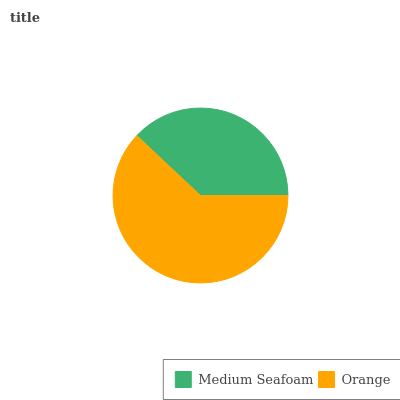Is Medium Seafoam the minimum?
Answer yes or no. Yes. Is Orange the maximum?
Answer yes or no. Yes. Is Orange the minimum?
Answer yes or no. No. Is Orange greater than Medium Seafoam?
Answer yes or no. Yes. Is Medium Seafoam less than Orange?
Answer yes or no. Yes. Is Medium Seafoam greater than Orange?
Answer yes or no. No. Is Orange less than Medium Seafoam?
Answer yes or no. No. Is Orange the high median?
Answer yes or no. Yes. Is Medium Seafoam the low median?
Answer yes or no. Yes. Is Medium Seafoam the high median?
Answer yes or no. No. Is Orange the low median?
Answer yes or no. No. 